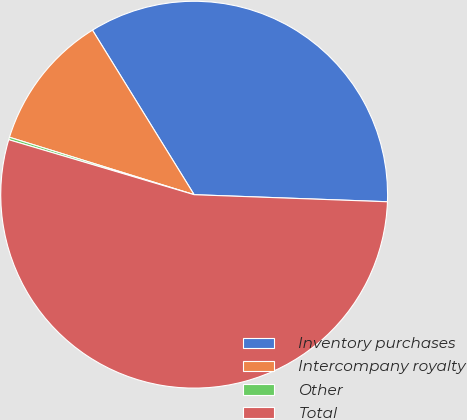<chart> <loc_0><loc_0><loc_500><loc_500><pie_chart><fcel>Inventory purchases<fcel>Intercompany royalty<fcel>Other<fcel>Total<nl><fcel>34.39%<fcel>11.39%<fcel>0.21%<fcel>54.01%<nl></chart> 